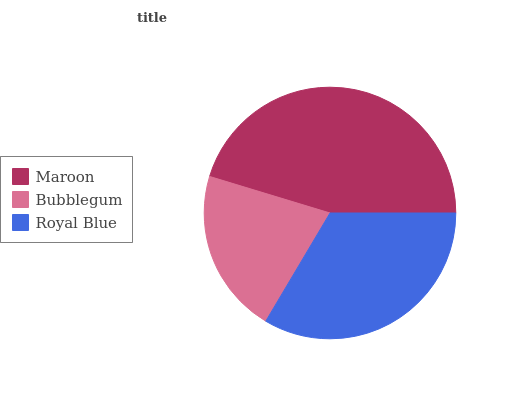Is Bubblegum the minimum?
Answer yes or no. Yes. Is Maroon the maximum?
Answer yes or no. Yes. Is Royal Blue the minimum?
Answer yes or no. No. Is Royal Blue the maximum?
Answer yes or no. No. Is Royal Blue greater than Bubblegum?
Answer yes or no. Yes. Is Bubblegum less than Royal Blue?
Answer yes or no. Yes. Is Bubblegum greater than Royal Blue?
Answer yes or no. No. Is Royal Blue less than Bubblegum?
Answer yes or no. No. Is Royal Blue the high median?
Answer yes or no. Yes. Is Royal Blue the low median?
Answer yes or no. Yes. Is Bubblegum the high median?
Answer yes or no. No. Is Bubblegum the low median?
Answer yes or no. No. 